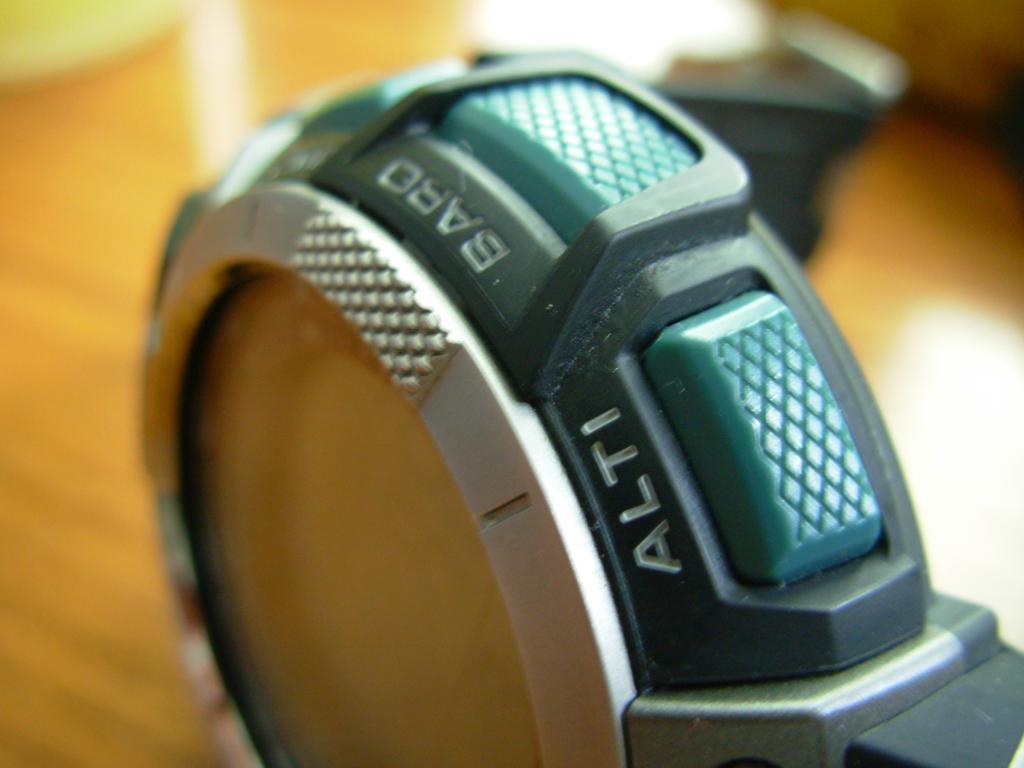Can you describe this image briefly? We can see watch. In the background it is blur. 